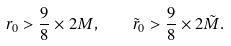Convert formula to latex. <formula><loc_0><loc_0><loc_500><loc_500>r _ { 0 } > \frac { 9 } { 8 } \times 2 M , \quad \tilde { r } _ { 0 } > \frac { 9 } { 8 } \times 2 \tilde { M } .</formula> 